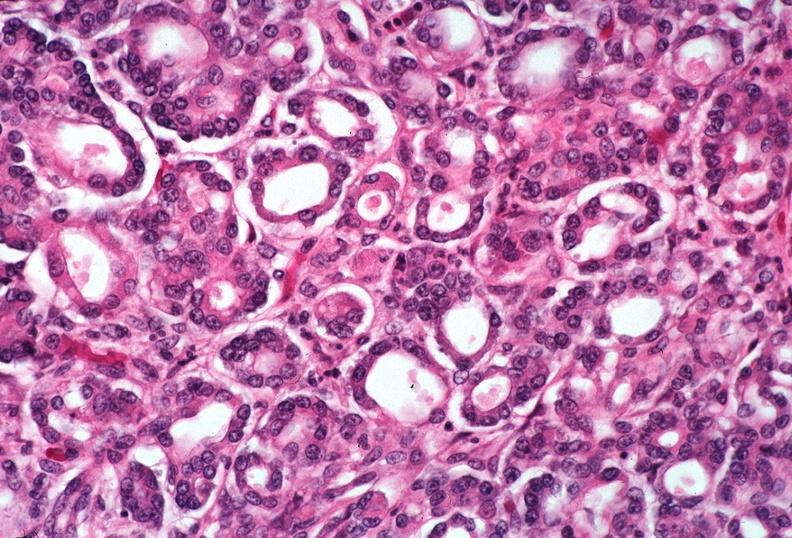where is this?
Answer the question using a single word or phrase. Pancreas 